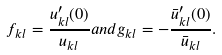Convert formula to latex. <formula><loc_0><loc_0><loc_500><loc_500>f _ { k l } = \frac { u ^ { \prime } _ { k l } ( 0 ) } { u _ { k l } } a n d g _ { k l } = - \frac { \bar { u } ^ { \prime } _ { k l } ( 0 ) } { \bar { u } _ { k l } } .</formula> 